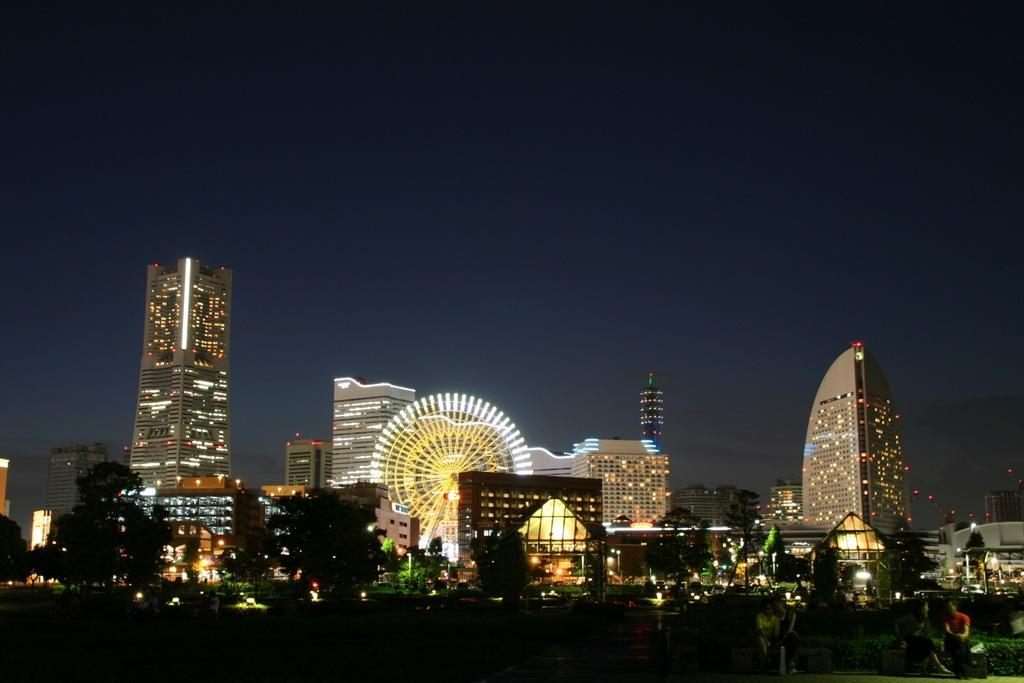What type of structures are visible in the image? There are buildings with lighting in the image. What are the people in the image doing? The people are seated in the image. What type of natural elements can be seen in the image? There are trees in the image. What is the lighting condition in the image? The image was taken in the dark. Can you see the breath of the people in the image? There is no indication of breath visible in the image, as it was taken in the dark and the focus is on the buildings, people, and trees. How many ducks are present in the image? There are no ducks present in the image; it features buildings, people, and trees. 